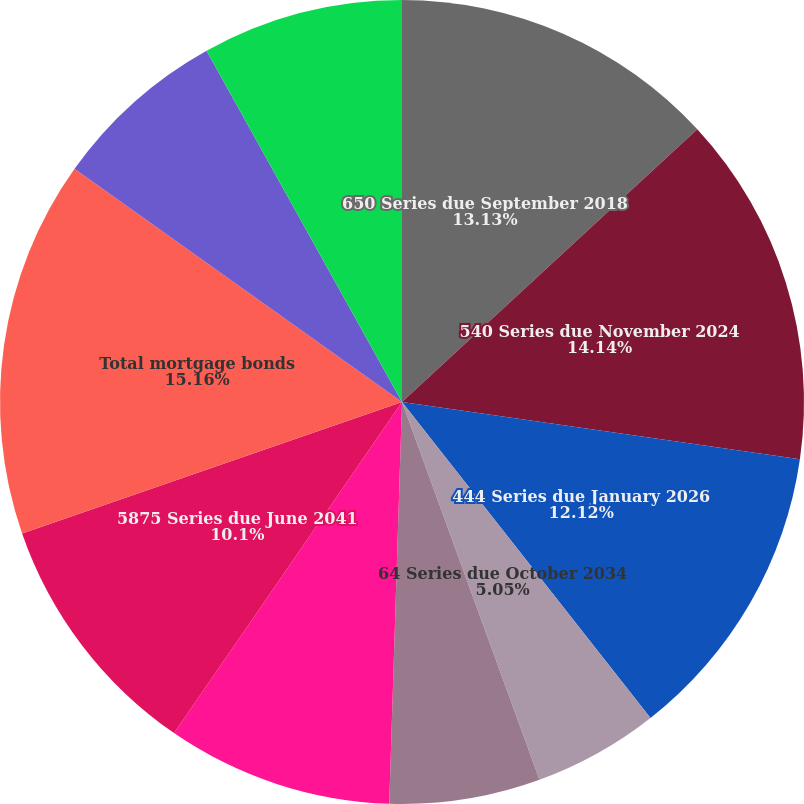<chart> <loc_0><loc_0><loc_500><loc_500><pie_chart><fcel>650 Series due September 2018<fcel>540 Series due November 2024<fcel>444 Series due January 2026<fcel>64 Series due October 2034<fcel>63 Series due September 2035<fcel>60 Series due March 2040<fcel>5875 Series due June 2041<fcel>Total mortgage bonds<fcel>50 Series due 2030 Louisiana<fcel>Total governmental bonds<nl><fcel>13.13%<fcel>14.14%<fcel>12.12%<fcel>5.05%<fcel>6.06%<fcel>9.09%<fcel>10.1%<fcel>15.15%<fcel>7.07%<fcel>8.08%<nl></chart> 